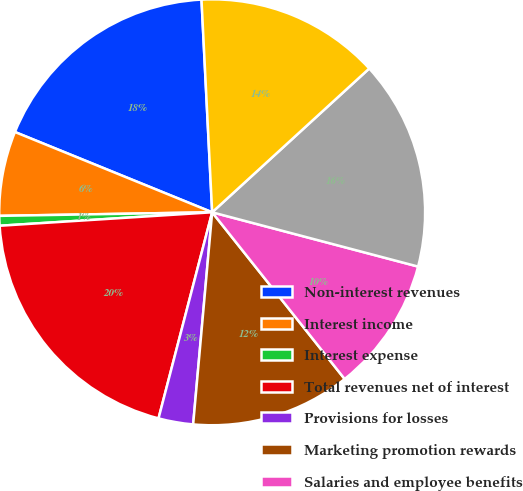Convert chart. <chart><loc_0><loc_0><loc_500><loc_500><pie_chart><fcel>Non-interest revenues<fcel>Interest income<fcel>Interest expense<fcel>Total revenues net of interest<fcel>Provisions for losses<fcel>Marketing promotion rewards<fcel>Salaries and employee benefits<fcel>Total expenses<fcel>Pretax segment income<nl><fcel>18.05%<fcel>6.42%<fcel>0.74%<fcel>19.94%<fcel>2.63%<fcel>12.11%<fcel>10.21%<fcel>15.9%<fcel>14.0%<nl></chart> 